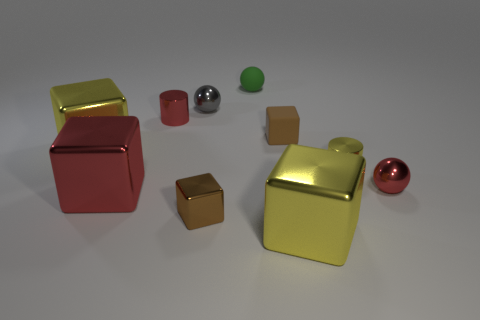Subtract all metallic spheres. How many spheres are left? 1 Subtract all yellow cylinders. How many cylinders are left? 1 Add 4 metal cylinders. How many metal cylinders are left? 6 Add 1 gray rubber cubes. How many gray rubber cubes exist? 1 Subtract 0 purple blocks. How many objects are left? 10 Subtract all balls. How many objects are left? 7 Subtract 2 cubes. How many cubes are left? 3 Subtract all yellow cylinders. Subtract all yellow blocks. How many cylinders are left? 1 Subtract all blue cylinders. How many brown cubes are left? 2 Subtract all tiny green shiny objects. Subtract all red metallic cylinders. How many objects are left? 9 